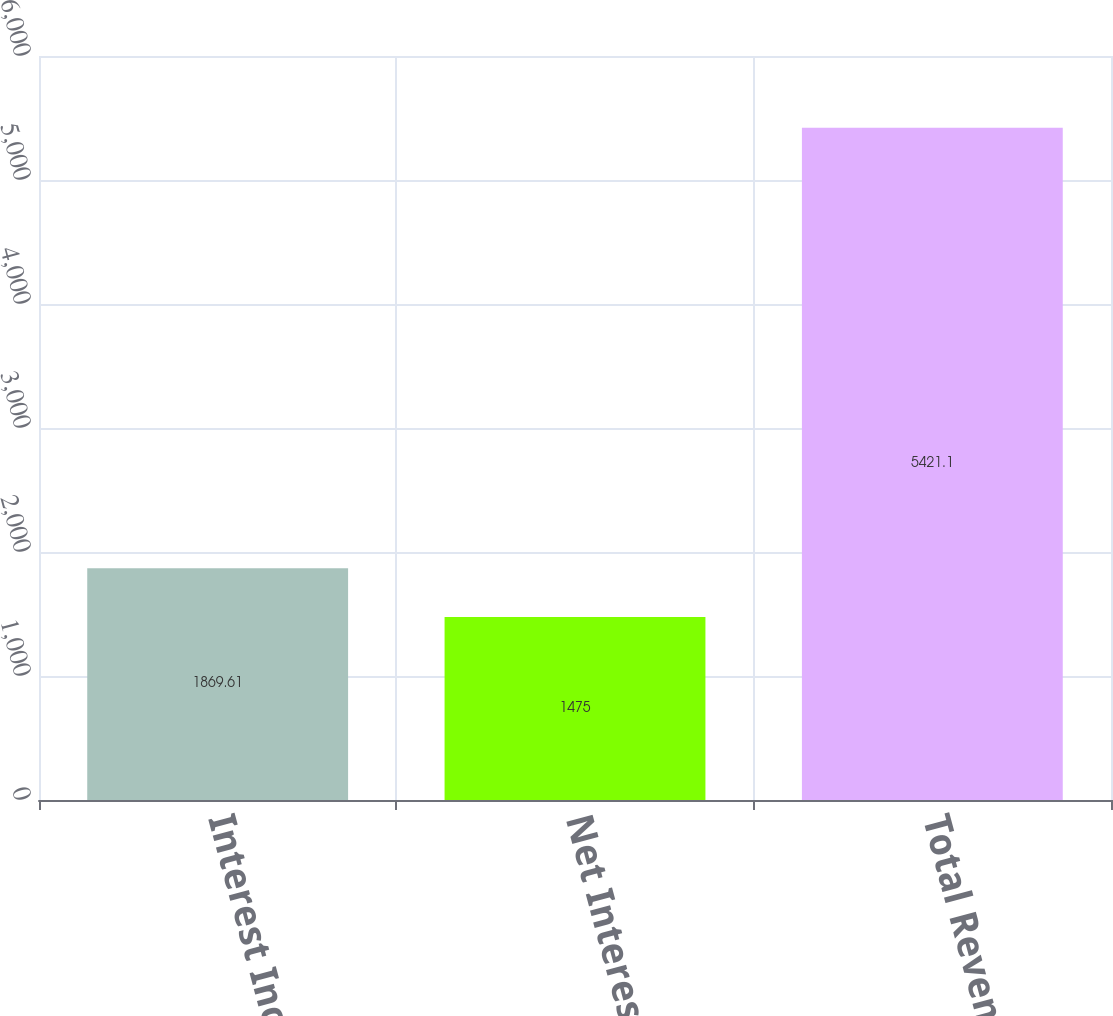Convert chart to OTSL. <chart><loc_0><loc_0><loc_500><loc_500><bar_chart><fcel>Interest Income<fcel>Net Interest Income<fcel>Total Revenue<nl><fcel>1869.61<fcel>1475<fcel>5421.1<nl></chart> 